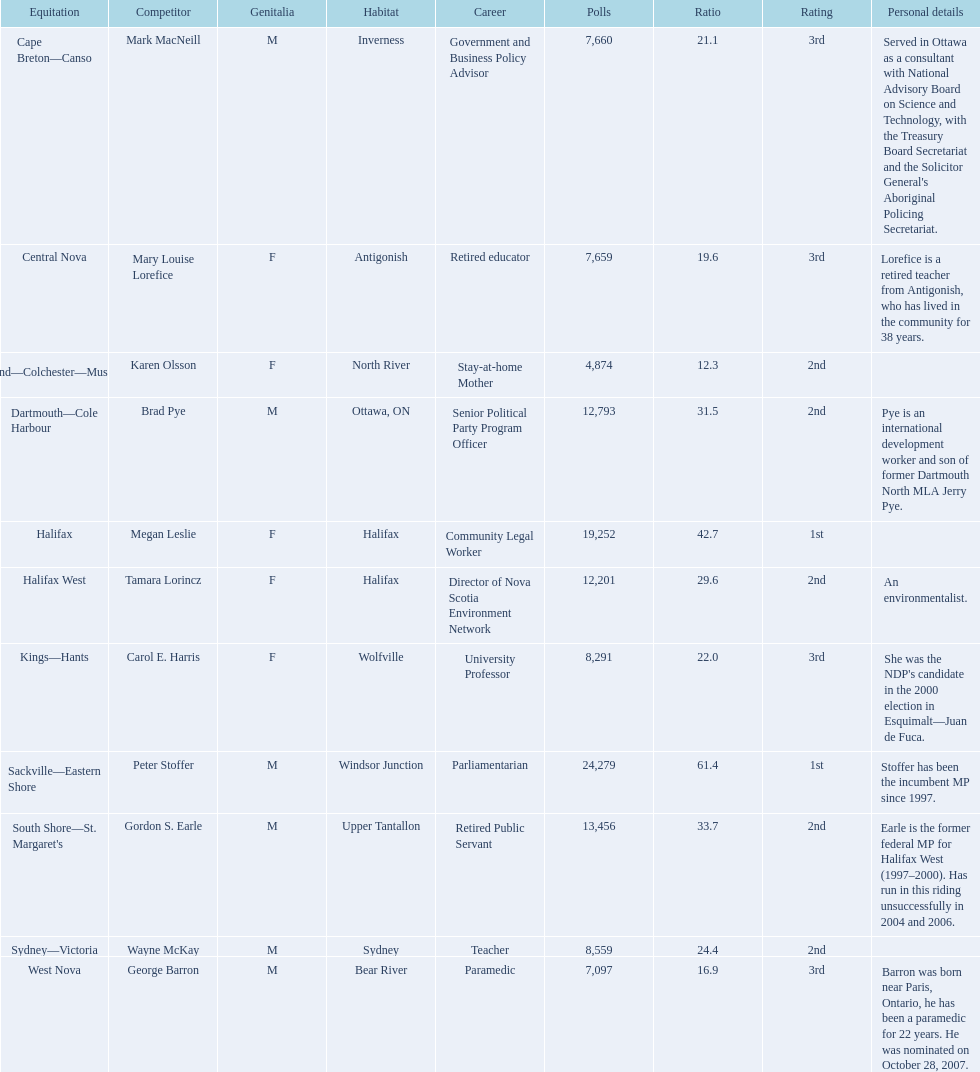What is the first riding? Cape Breton-Canso. 